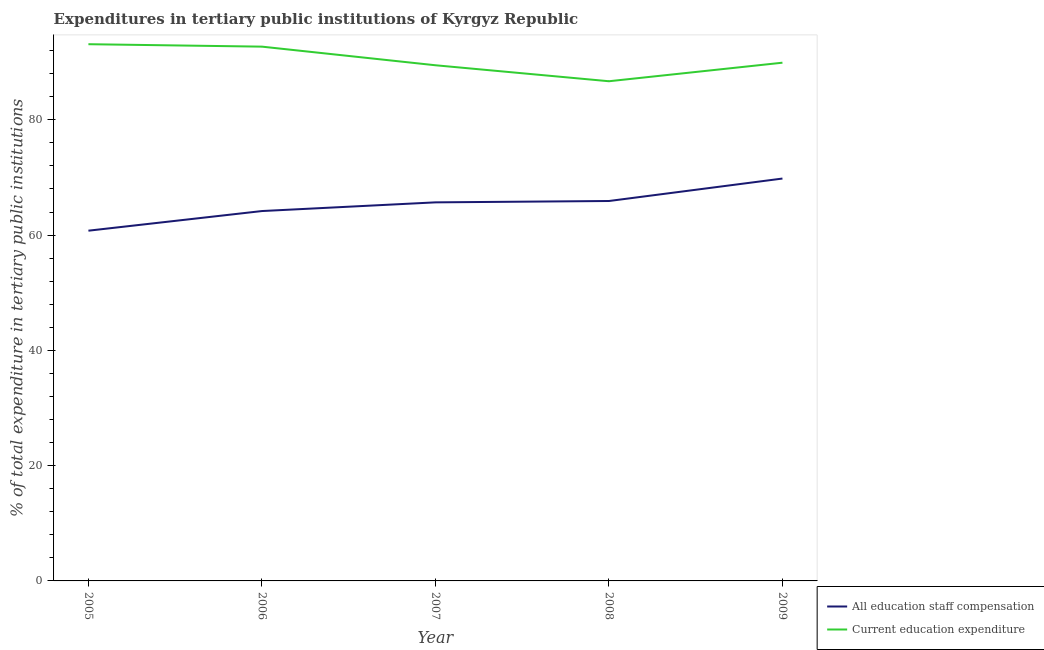How many different coloured lines are there?
Make the answer very short. 2. Does the line corresponding to expenditure in education intersect with the line corresponding to expenditure in staff compensation?
Provide a short and direct response. No. Is the number of lines equal to the number of legend labels?
Provide a short and direct response. Yes. What is the expenditure in education in 2005?
Make the answer very short. 93.12. Across all years, what is the maximum expenditure in education?
Keep it short and to the point. 93.12. Across all years, what is the minimum expenditure in education?
Provide a short and direct response. 86.69. In which year was the expenditure in education maximum?
Ensure brevity in your answer.  2005. What is the total expenditure in education in the graph?
Offer a very short reply. 451.88. What is the difference between the expenditure in education in 2006 and that in 2008?
Your response must be concise. 6. What is the difference between the expenditure in staff compensation in 2006 and the expenditure in education in 2005?
Give a very brief answer. -28.95. What is the average expenditure in education per year?
Your answer should be very brief. 90.38. In the year 2009, what is the difference between the expenditure in staff compensation and expenditure in education?
Give a very brief answer. -20.1. What is the ratio of the expenditure in staff compensation in 2007 to that in 2009?
Offer a very short reply. 0.94. What is the difference between the highest and the second highest expenditure in staff compensation?
Provide a succinct answer. 3.9. What is the difference between the highest and the lowest expenditure in staff compensation?
Offer a very short reply. 9.05. In how many years, is the expenditure in education greater than the average expenditure in education taken over all years?
Provide a short and direct response. 2. Is the sum of the expenditure in staff compensation in 2006 and 2007 greater than the maximum expenditure in education across all years?
Your response must be concise. Yes. Does the expenditure in staff compensation monotonically increase over the years?
Give a very brief answer. Yes. Is the expenditure in education strictly greater than the expenditure in staff compensation over the years?
Keep it short and to the point. Yes. How many lines are there?
Your response must be concise. 2. How many years are there in the graph?
Make the answer very short. 5. What is the difference between two consecutive major ticks on the Y-axis?
Provide a succinct answer. 20. Are the values on the major ticks of Y-axis written in scientific E-notation?
Make the answer very short. No. Does the graph contain any zero values?
Give a very brief answer. No. How many legend labels are there?
Your answer should be very brief. 2. What is the title of the graph?
Ensure brevity in your answer.  Expenditures in tertiary public institutions of Kyrgyz Republic. What is the label or title of the X-axis?
Provide a succinct answer. Year. What is the label or title of the Y-axis?
Offer a very short reply. % of total expenditure in tertiary public institutions. What is the % of total expenditure in tertiary public institutions of All education staff compensation in 2005?
Your answer should be very brief. 60.76. What is the % of total expenditure in tertiary public institutions in Current education expenditure in 2005?
Provide a short and direct response. 93.12. What is the % of total expenditure in tertiary public institutions of All education staff compensation in 2006?
Your answer should be compact. 64.17. What is the % of total expenditure in tertiary public institutions of Current education expenditure in 2006?
Make the answer very short. 92.7. What is the % of total expenditure in tertiary public institutions in All education staff compensation in 2007?
Make the answer very short. 65.68. What is the % of total expenditure in tertiary public institutions in Current education expenditure in 2007?
Ensure brevity in your answer.  89.47. What is the % of total expenditure in tertiary public institutions of All education staff compensation in 2008?
Ensure brevity in your answer.  65.91. What is the % of total expenditure in tertiary public institutions in Current education expenditure in 2008?
Offer a terse response. 86.69. What is the % of total expenditure in tertiary public institutions of All education staff compensation in 2009?
Make the answer very short. 69.81. What is the % of total expenditure in tertiary public institutions of Current education expenditure in 2009?
Keep it short and to the point. 89.91. Across all years, what is the maximum % of total expenditure in tertiary public institutions in All education staff compensation?
Offer a terse response. 69.81. Across all years, what is the maximum % of total expenditure in tertiary public institutions in Current education expenditure?
Provide a succinct answer. 93.12. Across all years, what is the minimum % of total expenditure in tertiary public institutions in All education staff compensation?
Provide a short and direct response. 60.76. Across all years, what is the minimum % of total expenditure in tertiary public institutions in Current education expenditure?
Keep it short and to the point. 86.69. What is the total % of total expenditure in tertiary public institutions of All education staff compensation in the graph?
Give a very brief answer. 326.34. What is the total % of total expenditure in tertiary public institutions of Current education expenditure in the graph?
Offer a very short reply. 451.88. What is the difference between the % of total expenditure in tertiary public institutions in All education staff compensation in 2005 and that in 2006?
Make the answer very short. -3.41. What is the difference between the % of total expenditure in tertiary public institutions in Current education expenditure in 2005 and that in 2006?
Make the answer very short. 0.42. What is the difference between the % of total expenditure in tertiary public institutions in All education staff compensation in 2005 and that in 2007?
Ensure brevity in your answer.  -4.91. What is the difference between the % of total expenditure in tertiary public institutions of Current education expenditure in 2005 and that in 2007?
Make the answer very short. 3.65. What is the difference between the % of total expenditure in tertiary public institutions of All education staff compensation in 2005 and that in 2008?
Keep it short and to the point. -5.15. What is the difference between the % of total expenditure in tertiary public institutions in Current education expenditure in 2005 and that in 2008?
Your response must be concise. 6.43. What is the difference between the % of total expenditure in tertiary public institutions of All education staff compensation in 2005 and that in 2009?
Give a very brief answer. -9.05. What is the difference between the % of total expenditure in tertiary public institutions in Current education expenditure in 2005 and that in 2009?
Provide a succinct answer. 3.21. What is the difference between the % of total expenditure in tertiary public institutions in All education staff compensation in 2006 and that in 2007?
Ensure brevity in your answer.  -1.51. What is the difference between the % of total expenditure in tertiary public institutions in Current education expenditure in 2006 and that in 2007?
Make the answer very short. 3.23. What is the difference between the % of total expenditure in tertiary public institutions of All education staff compensation in 2006 and that in 2008?
Offer a terse response. -1.74. What is the difference between the % of total expenditure in tertiary public institutions in Current education expenditure in 2006 and that in 2008?
Your answer should be very brief. 6. What is the difference between the % of total expenditure in tertiary public institutions in All education staff compensation in 2006 and that in 2009?
Make the answer very short. -5.64. What is the difference between the % of total expenditure in tertiary public institutions in Current education expenditure in 2006 and that in 2009?
Give a very brief answer. 2.78. What is the difference between the % of total expenditure in tertiary public institutions in All education staff compensation in 2007 and that in 2008?
Offer a terse response. -0.24. What is the difference between the % of total expenditure in tertiary public institutions in Current education expenditure in 2007 and that in 2008?
Your response must be concise. 2.77. What is the difference between the % of total expenditure in tertiary public institutions in All education staff compensation in 2007 and that in 2009?
Your answer should be very brief. -4.13. What is the difference between the % of total expenditure in tertiary public institutions in Current education expenditure in 2007 and that in 2009?
Make the answer very short. -0.45. What is the difference between the % of total expenditure in tertiary public institutions of All education staff compensation in 2008 and that in 2009?
Give a very brief answer. -3.9. What is the difference between the % of total expenditure in tertiary public institutions of Current education expenditure in 2008 and that in 2009?
Ensure brevity in your answer.  -3.22. What is the difference between the % of total expenditure in tertiary public institutions of All education staff compensation in 2005 and the % of total expenditure in tertiary public institutions of Current education expenditure in 2006?
Offer a very short reply. -31.93. What is the difference between the % of total expenditure in tertiary public institutions in All education staff compensation in 2005 and the % of total expenditure in tertiary public institutions in Current education expenditure in 2007?
Offer a terse response. -28.7. What is the difference between the % of total expenditure in tertiary public institutions in All education staff compensation in 2005 and the % of total expenditure in tertiary public institutions in Current education expenditure in 2008?
Provide a short and direct response. -25.93. What is the difference between the % of total expenditure in tertiary public institutions of All education staff compensation in 2005 and the % of total expenditure in tertiary public institutions of Current education expenditure in 2009?
Your answer should be compact. -29.15. What is the difference between the % of total expenditure in tertiary public institutions in All education staff compensation in 2006 and the % of total expenditure in tertiary public institutions in Current education expenditure in 2007?
Offer a terse response. -25.29. What is the difference between the % of total expenditure in tertiary public institutions of All education staff compensation in 2006 and the % of total expenditure in tertiary public institutions of Current education expenditure in 2008?
Provide a short and direct response. -22.52. What is the difference between the % of total expenditure in tertiary public institutions in All education staff compensation in 2006 and the % of total expenditure in tertiary public institutions in Current education expenditure in 2009?
Your response must be concise. -25.74. What is the difference between the % of total expenditure in tertiary public institutions in All education staff compensation in 2007 and the % of total expenditure in tertiary public institutions in Current education expenditure in 2008?
Make the answer very short. -21.01. What is the difference between the % of total expenditure in tertiary public institutions of All education staff compensation in 2007 and the % of total expenditure in tertiary public institutions of Current education expenditure in 2009?
Keep it short and to the point. -24.23. What is the difference between the % of total expenditure in tertiary public institutions of All education staff compensation in 2008 and the % of total expenditure in tertiary public institutions of Current education expenditure in 2009?
Provide a short and direct response. -24. What is the average % of total expenditure in tertiary public institutions of All education staff compensation per year?
Offer a very short reply. 65.27. What is the average % of total expenditure in tertiary public institutions of Current education expenditure per year?
Your response must be concise. 90.38. In the year 2005, what is the difference between the % of total expenditure in tertiary public institutions in All education staff compensation and % of total expenditure in tertiary public institutions in Current education expenditure?
Offer a terse response. -32.35. In the year 2006, what is the difference between the % of total expenditure in tertiary public institutions in All education staff compensation and % of total expenditure in tertiary public institutions in Current education expenditure?
Offer a very short reply. -28.52. In the year 2007, what is the difference between the % of total expenditure in tertiary public institutions of All education staff compensation and % of total expenditure in tertiary public institutions of Current education expenditure?
Offer a terse response. -23.79. In the year 2008, what is the difference between the % of total expenditure in tertiary public institutions in All education staff compensation and % of total expenditure in tertiary public institutions in Current education expenditure?
Provide a short and direct response. -20.78. In the year 2009, what is the difference between the % of total expenditure in tertiary public institutions in All education staff compensation and % of total expenditure in tertiary public institutions in Current education expenditure?
Make the answer very short. -20.1. What is the ratio of the % of total expenditure in tertiary public institutions of All education staff compensation in 2005 to that in 2006?
Offer a very short reply. 0.95. What is the ratio of the % of total expenditure in tertiary public institutions of Current education expenditure in 2005 to that in 2006?
Give a very brief answer. 1. What is the ratio of the % of total expenditure in tertiary public institutions of All education staff compensation in 2005 to that in 2007?
Offer a very short reply. 0.93. What is the ratio of the % of total expenditure in tertiary public institutions of Current education expenditure in 2005 to that in 2007?
Give a very brief answer. 1.04. What is the ratio of the % of total expenditure in tertiary public institutions in All education staff compensation in 2005 to that in 2008?
Provide a short and direct response. 0.92. What is the ratio of the % of total expenditure in tertiary public institutions in Current education expenditure in 2005 to that in 2008?
Offer a terse response. 1.07. What is the ratio of the % of total expenditure in tertiary public institutions of All education staff compensation in 2005 to that in 2009?
Provide a succinct answer. 0.87. What is the ratio of the % of total expenditure in tertiary public institutions of Current education expenditure in 2005 to that in 2009?
Give a very brief answer. 1.04. What is the ratio of the % of total expenditure in tertiary public institutions of Current education expenditure in 2006 to that in 2007?
Ensure brevity in your answer.  1.04. What is the ratio of the % of total expenditure in tertiary public institutions of All education staff compensation in 2006 to that in 2008?
Offer a terse response. 0.97. What is the ratio of the % of total expenditure in tertiary public institutions in Current education expenditure in 2006 to that in 2008?
Your response must be concise. 1.07. What is the ratio of the % of total expenditure in tertiary public institutions of All education staff compensation in 2006 to that in 2009?
Offer a very short reply. 0.92. What is the ratio of the % of total expenditure in tertiary public institutions of Current education expenditure in 2006 to that in 2009?
Ensure brevity in your answer.  1.03. What is the ratio of the % of total expenditure in tertiary public institutions of Current education expenditure in 2007 to that in 2008?
Ensure brevity in your answer.  1.03. What is the ratio of the % of total expenditure in tertiary public institutions of All education staff compensation in 2007 to that in 2009?
Provide a short and direct response. 0.94. What is the ratio of the % of total expenditure in tertiary public institutions in Current education expenditure in 2007 to that in 2009?
Make the answer very short. 1. What is the ratio of the % of total expenditure in tertiary public institutions of All education staff compensation in 2008 to that in 2009?
Offer a terse response. 0.94. What is the ratio of the % of total expenditure in tertiary public institutions in Current education expenditure in 2008 to that in 2009?
Your answer should be very brief. 0.96. What is the difference between the highest and the second highest % of total expenditure in tertiary public institutions of All education staff compensation?
Your answer should be compact. 3.9. What is the difference between the highest and the second highest % of total expenditure in tertiary public institutions in Current education expenditure?
Make the answer very short. 0.42. What is the difference between the highest and the lowest % of total expenditure in tertiary public institutions in All education staff compensation?
Offer a very short reply. 9.05. What is the difference between the highest and the lowest % of total expenditure in tertiary public institutions of Current education expenditure?
Your answer should be very brief. 6.43. 